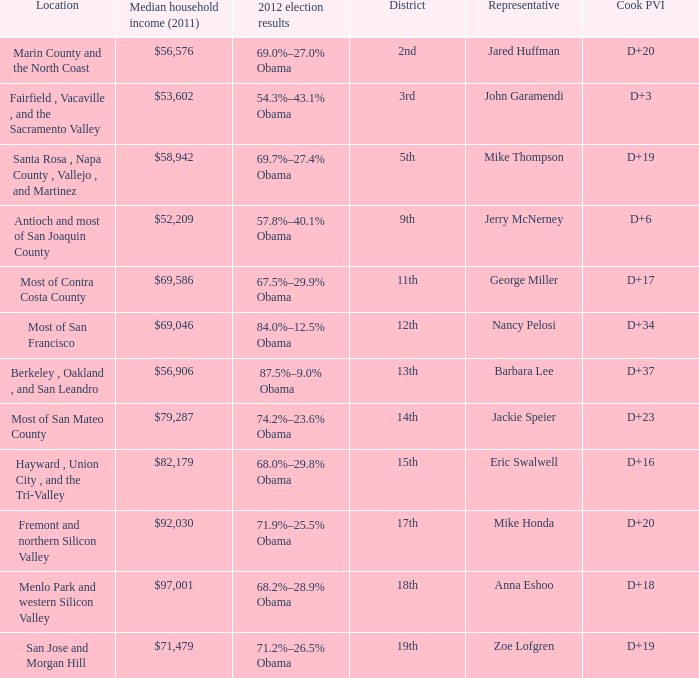What is the 2012 election results for locations whose representative is Barbara Lee? 87.5%–9.0% Obama. 